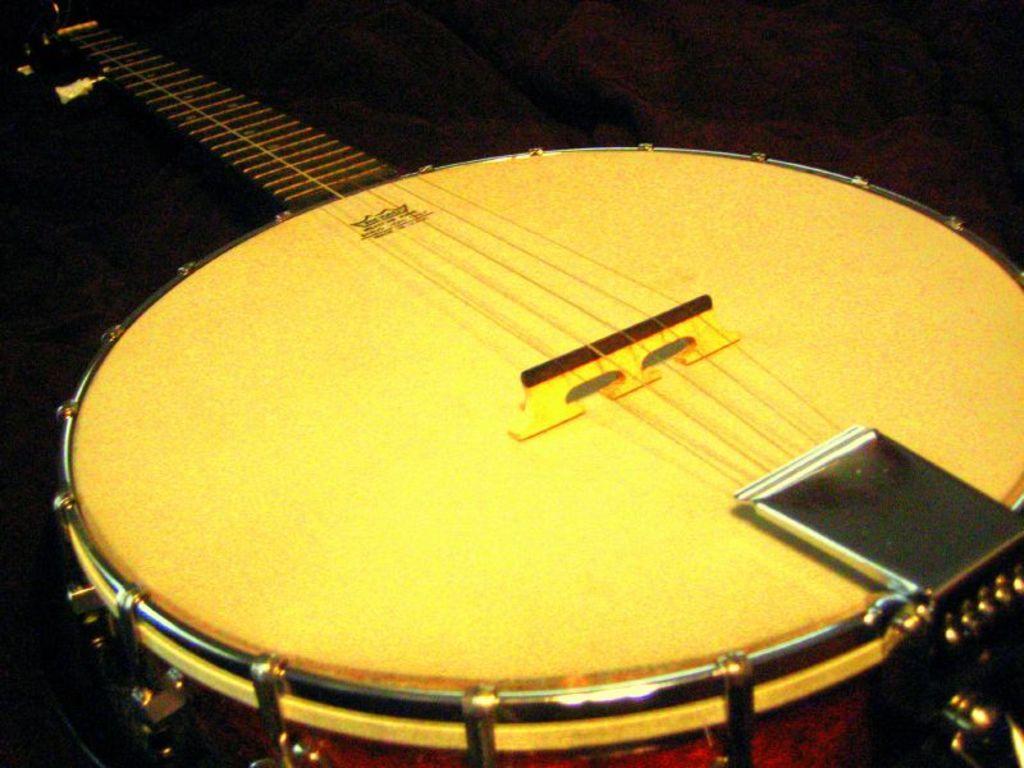Can you describe this image briefly? In this image, we can see a musical instrument. 